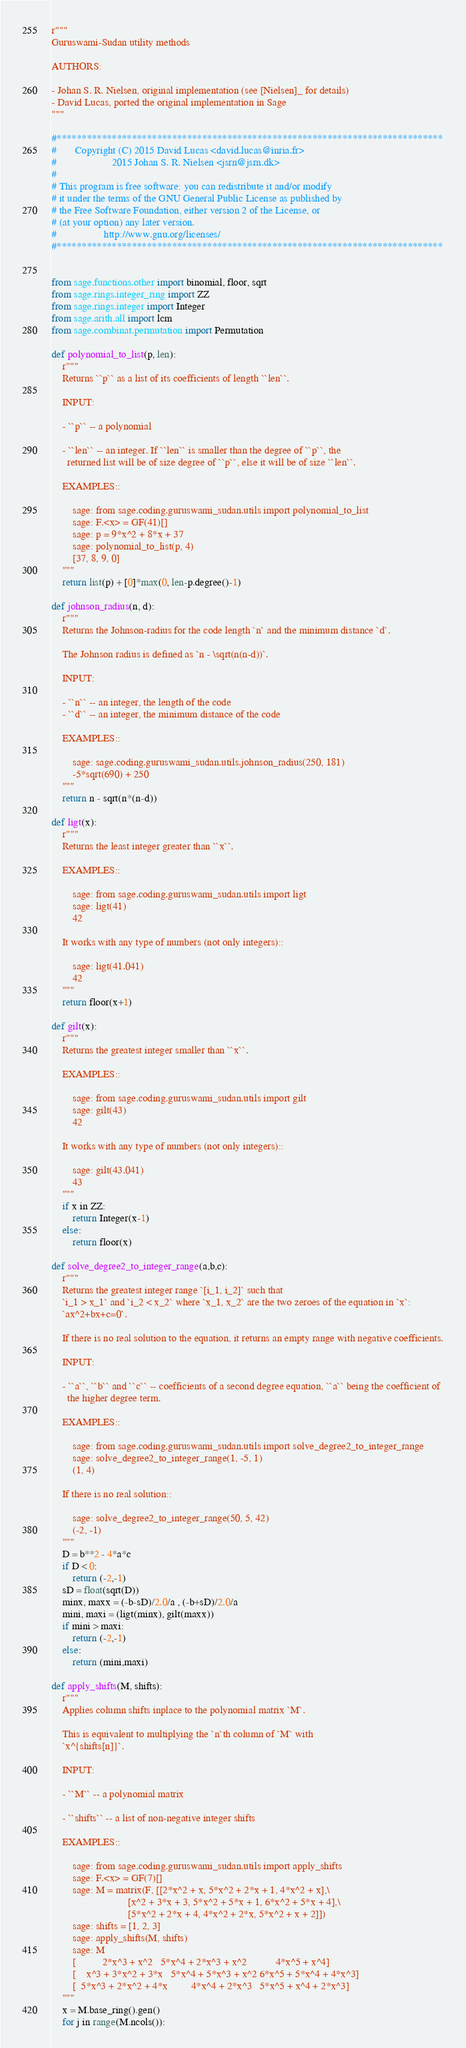Convert code to text. <code><loc_0><loc_0><loc_500><loc_500><_Python_>r"""
Guruswami-Sudan utility methods

AUTHORS:

- Johan S. R. Nielsen, original implementation (see [Nielsen]_ for details)
- David Lucas, ported the original implementation in Sage
"""

#*****************************************************************************
#       Copyright (C) 2015 David Lucas <david.lucas@inria.fr>
#                     2015 Johan S. R. Nielsen <jsrn@jsrn.dk>
#
# This program is free software: you can redistribute it and/or modify
# it under the terms of the GNU General Public License as published by
# the Free Software Foundation, either version 2 of the License, or
# (at your option) any later version.
#                  http://www.gnu.org/licenses/
#*****************************************************************************


from sage.functions.other import binomial, floor, sqrt
from sage.rings.integer_ring import ZZ
from sage.rings.integer import Integer
from sage.arith.all import lcm
from sage.combinat.permutation import Permutation

def polynomial_to_list(p, len):
    r"""
    Returns ``p`` as a list of its coefficients of length ``len``.

    INPUT:

    - ``p`` -- a polynomial

    - ``len`` -- an integer. If ``len`` is smaller than the degree of ``p``, the
      returned list will be of size degree of ``p``, else it will be of size ``len``.

    EXAMPLES::

        sage: from sage.coding.guruswami_sudan.utils import polynomial_to_list
        sage: F.<x> = GF(41)[]
        sage: p = 9*x^2 + 8*x + 37
        sage: polynomial_to_list(p, 4)
        [37, 8, 9, 0]
    """
    return list(p) + [0]*max(0, len-p.degree()-1)

def johnson_radius(n, d):
    r"""
    Returns the Johnson-radius for the code length `n` and the minimum distance `d`.

    The Johnson radius is defined as `n - \sqrt(n(n-d))`.

    INPUT:

    - ``n`` -- an integer, the length of the code
    - ``d`` -- an integer, the minimum distance of the code

    EXAMPLES::

        sage: sage.coding.guruswami_sudan.utils.johnson_radius(250, 181)
        -5*sqrt(690) + 250
    """
    return n - sqrt(n*(n-d))

def ligt(x):
    r"""
    Returns the least integer greater than ``x``.

    EXAMPLES::

        sage: from sage.coding.guruswami_sudan.utils import ligt
        sage: ligt(41)
        42

    It works with any type of numbers (not only integers)::

        sage: ligt(41.041)
        42
    """
    return floor(x+1)

def gilt(x):
    r"""
    Returns the greatest integer smaller than ``x``.

    EXAMPLES::

        sage: from sage.coding.guruswami_sudan.utils import gilt
        sage: gilt(43)
        42

    It works with any type of numbers (not only integers)::

        sage: gilt(43.041)
        43
    """
    if x in ZZ:
        return Integer(x-1)
    else:
        return floor(x)

def solve_degree2_to_integer_range(a,b,c):
    r"""
    Returns the greatest integer range `[i_1, i_2]` such that
    `i_1 > x_1` and `i_2 < x_2` where `x_1, x_2` are the two zeroes of the equation in `x`:
    `ax^2+bx+c=0`.

    If there is no real solution to the equation, it returns an empty range with negative coefficients.

    INPUT:

    - ``a``, ``b`` and ``c`` -- coefficients of a second degree equation, ``a`` being the coefficient of
      the higher degree term.

    EXAMPLES::

        sage: from sage.coding.guruswami_sudan.utils import solve_degree2_to_integer_range
        sage: solve_degree2_to_integer_range(1, -5, 1)
        (1, 4)

    If there is no real solution::

        sage: solve_degree2_to_integer_range(50, 5, 42)
        (-2, -1)
    """
    D = b**2 - 4*a*c
    if D < 0:
        return (-2,-1)
    sD = float(sqrt(D))
    minx, maxx = (-b-sD)/2.0/a , (-b+sD)/2.0/a
    mini, maxi = (ligt(minx), gilt(maxx))
    if mini > maxi:
        return (-2,-1)
    else:
        return (mini,maxi)

def apply_shifts(M, shifts):
    r"""
    Applies column shifts inplace to the polynomial matrix `M`.

    This is equivalent to multiplying the `n`th column of `M` with
    `x^{shifts[n]}`.

    INPUT:

    - ``M`` -- a polynomial matrix

    - ``shifts`` -- a list of non-negative integer shifts

    EXAMPLES::

        sage: from sage.coding.guruswami_sudan.utils import apply_shifts
        sage: F.<x> = GF(7)[]
        sage: M = matrix(F, [[2*x^2 + x, 5*x^2 + 2*x + 1, 4*x^2 + x],\
                             [x^2 + 3*x + 3, 5*x^2 + 5*x + 1, 6*x^2 + 5*x + 4],\
                             [5*x^2 + 2*x + 4, 4*x^2 + 2*x, 5*x^2 + x + 2]])
        sage: shifts = [1, 2, 3]
        sage: apply_shifts(M, shifts)
        sage: M
        [          2*x^3 + x^2   5*x^4 + 2*x^3 + x^2           4*x^5 + x^4]
        [    x^3 + 3*x^2 + 3*x   5*x^4 + 5*x^3 + x^2 6*x^5 + 5*x^4 + 4*x^3]
        [  5*x^3 + 2*x^2 + 4*x         4*x^4 + 2*x^3   5*x^5 + x^4 + 2*x^3]
    """
    x = M.base_ring().gen()
    for j in range(M.ncols()):</code> 